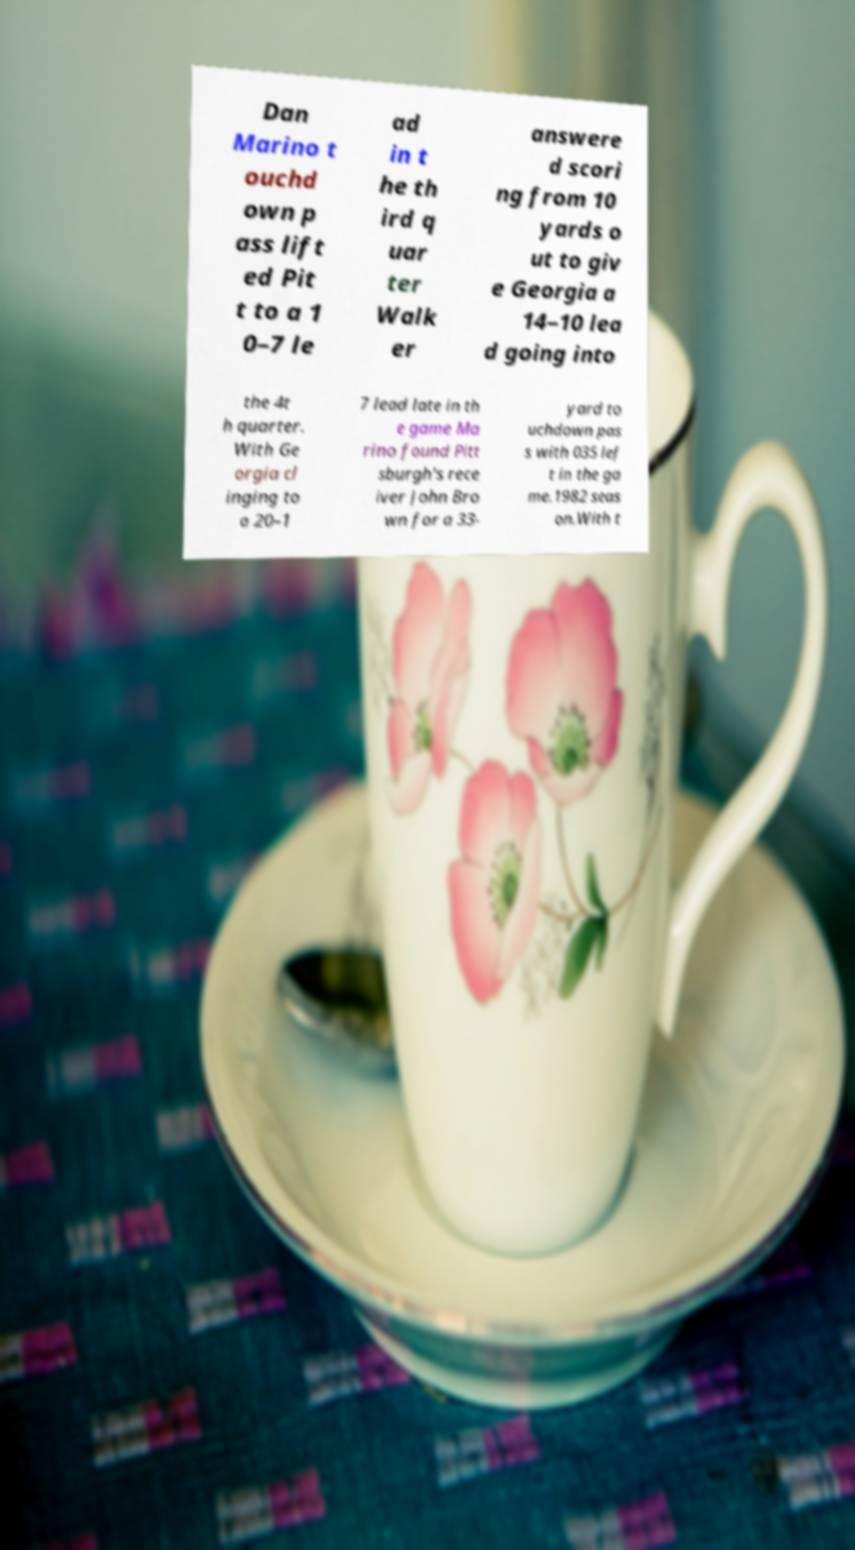Can you accurately transcribe the text from the provided image for me? Dan Marino t ouchd own p ass lift ed Pit t to a 1 0–7 le ad in t he th ird q uar ter Walk er answere d scori ng from 10 yards o ut to giv e Georgia a 14–10 lea d going into the 4t h quarter. With Ge orgia cl inging to a 20–1 7 lead late in th e game Ma rino found Pitt sburgh's rece iver John Bro wn for a 33- yard to uchdown pas s with 035 lef t in the ga me.1982 seas on.With t 